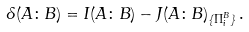<formula> <loc_0><loc_0><loc_500><loc_500>\delta ( A \colon B ) = I ( A \colon B ) - J ( A \colon B ) _ { \{ \Pi _ { i } ^ { B } \} } \, .</formula> 